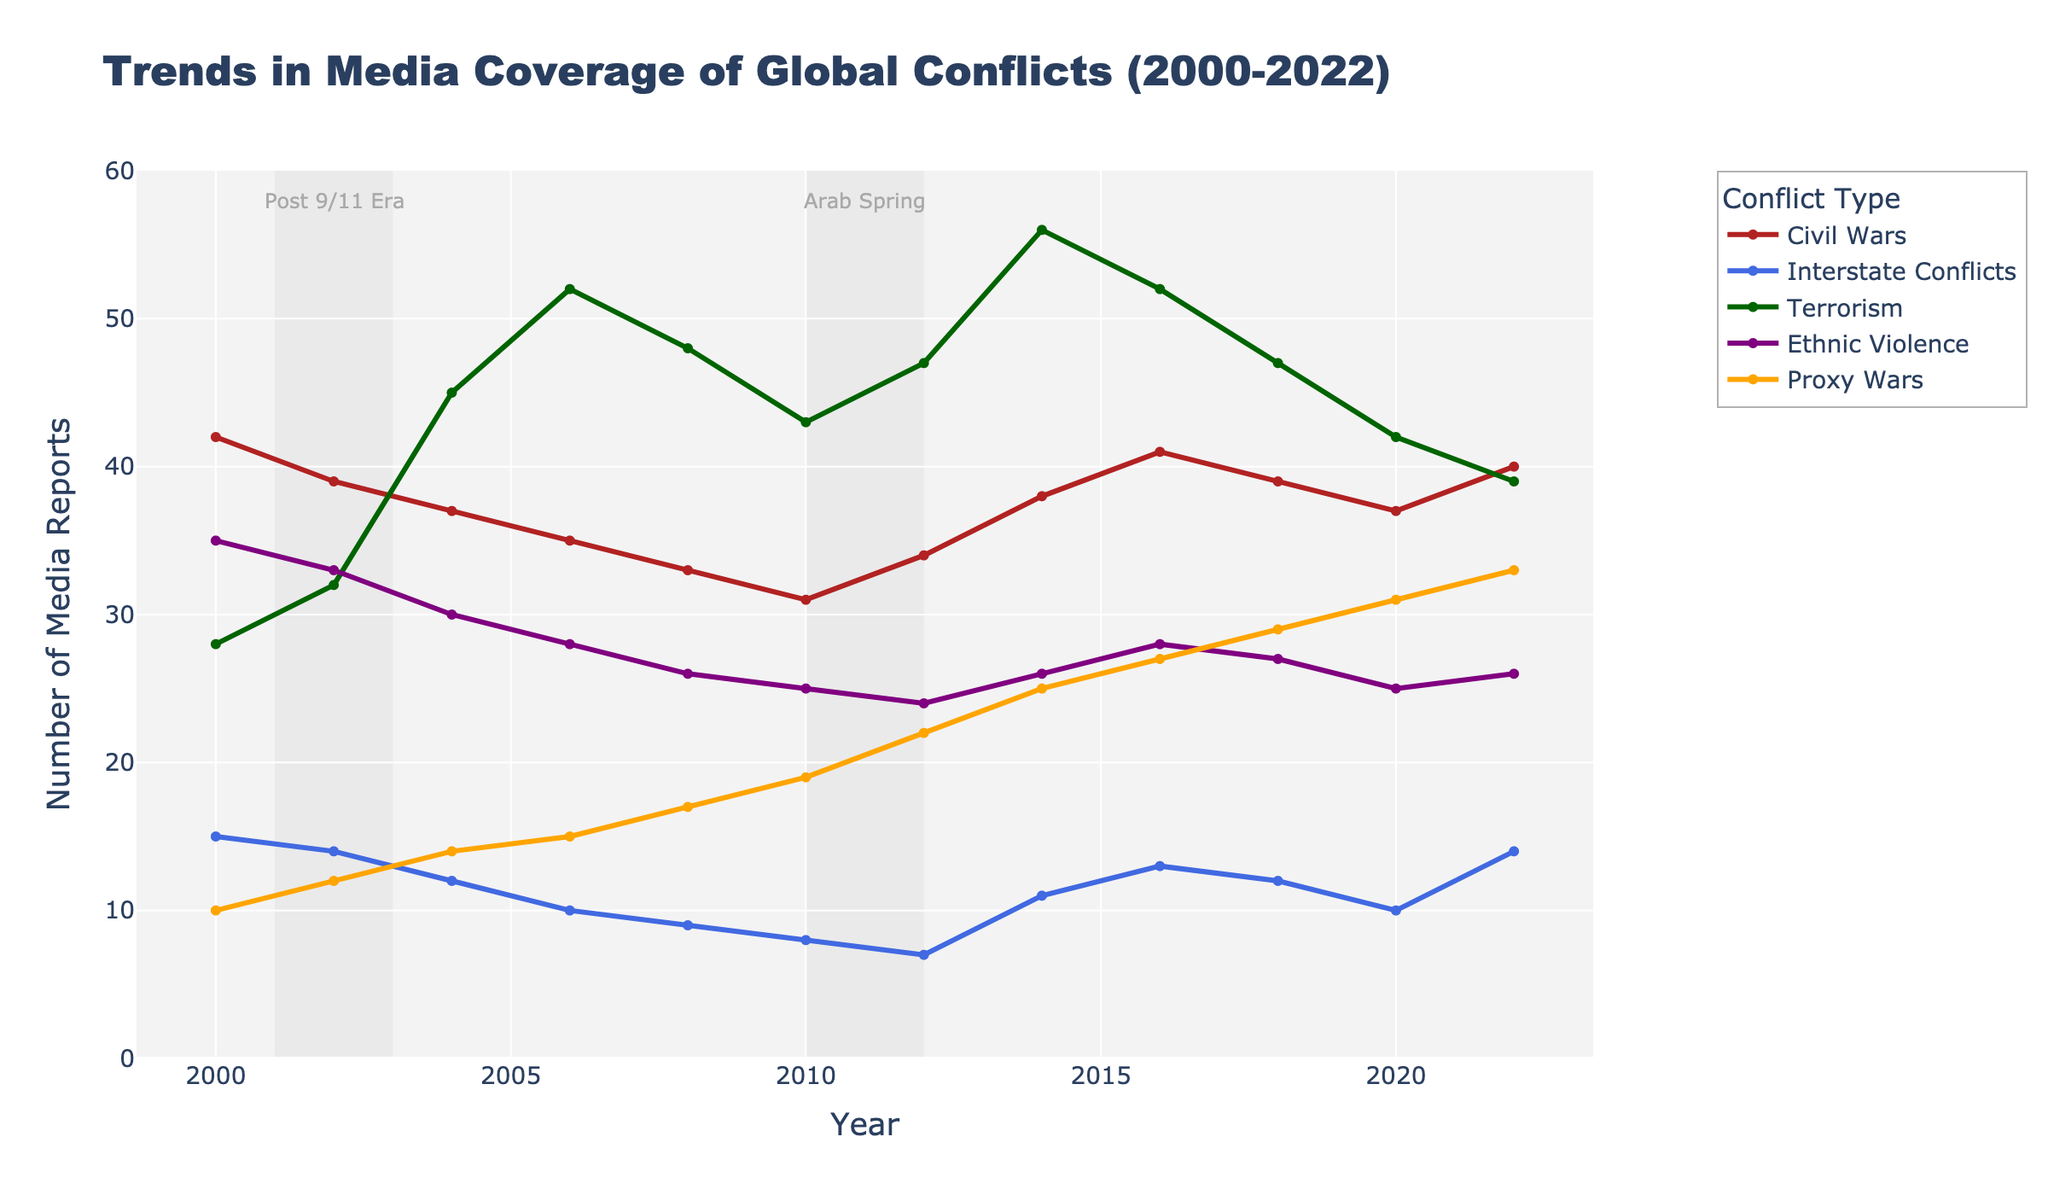What conflict type experienced the highest number of media reports in 2014? To identify the conflict type with the highest media reports in 2014, look for the highest point along the y-axis for the year 2014. "Terrorism" has a peak value of 56 in that year.
Answer: Terrorism How did the media coverage of Civil Wars change between 2000 and 2022? Look at the data points for Civil Wars at the start (2000 with 42 reports) and end (2022 with 40 reports) of the timeline. Subtract the initial from the final value (40 - 42 = -2).
Answer: Decreased by 2 Which period is highlighted as the "Post 9/11 Era," and how did media coverage of Terrorism change during that time? The "Post 9/11 Era" spans from 2001 to 2003, marked by a gray rectangle. Media coverage of Terrorism increased from 28 in 2000 to 32 in 2002, then to 45 in 2004.
Answer: Increased Compare the trends in media coverage of Interstate Conflicts and Proxy Wars between 2010 and 2022. Which one shows a more significant increase? For Interstate Conflicts, the values are 8 in 2010 and 14 in 2022, showing an increase of 6 (14 - 8). For Proxy Wars, the values are 19 in 2010 and 33 in 2022, showing an increase of 14 (33 - 19). Thus, Proxy Wars show a more significant increase.
Answer: Proxy Wars During which year did Ethnic Violence receive the lowest media coverage? Look for the lowest data point for Ethnic Violence. This occurs in 2012, where the value is 24.
Answer: 2012 Calculate the average number of media reports on Terrorism across the entire timeline. Add up all the yearly values for Terrorism (28 + 32 + 45 + 52 + 48 + 43 + 47 + 56 + 52 + 47 + 42 + 39 = 531) and divide by the number of years (531 / 12).
Answer: 44.25 In which year did media coverage of Proxy Wars surpass the 30-report mark? Look for the first year where Proxy Wars have a value greater than 30. This happens in 2020 with a value of 31.
Answer: 2020 What is the overall trend in media coverage of Interstate Conflicts from 2000 to 2022? To determine the overall trend, compare the values from start (15 in 2000) to end (14 in 2022). There is a slight decrease over this period (15 - 14 = 1).
Answer: Slight decrease Is there a year where all conflict types show an increase in media coverage compared to the previous year? Check each year to see if all conflict types have higher values than the previous year. In 2014, all conflict types from 2012 show increases.
Answer: 2014 